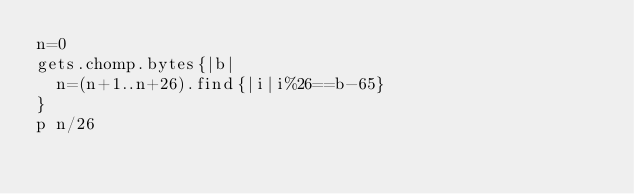<code> <loc_0><loc_0><loc_500><loc_500><_Ruby_>n=0
gets.chomp.bytes{|b|
	n=(n+1..n+26).find{|i|i%26==b-65}
}
p n/26</code> 